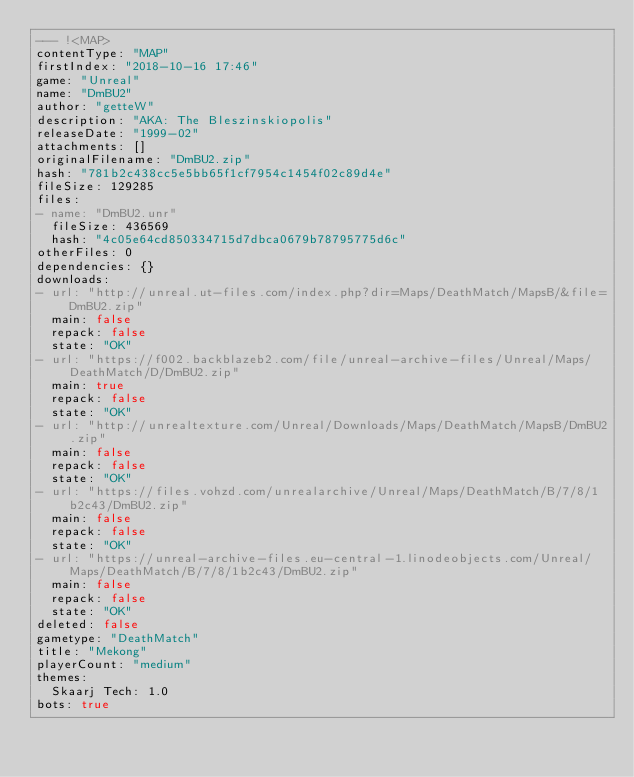Convert code to text. <code><loc_0><loc_0><loc_500><loc_500><_YAML_>--- !<MAP>
contentType: "MAP"
firstIndex: "2018-10-16 17:46"
game: "Unreal"
name: "DmBU2"
author: "getteW"
description: "AKA: The Bleszinskiopolis"
releaseDate: "1999-02"
attachments: []
originalFilename: "DmBU2.zip"
hash: "781b2c438cc5e5bb65f1cf7954c1454f02c89d4e"
fileSize: 129285
files:
- name: "DmBU2.unr"
  fileSize: 436569
  hash: "4c05e64cd850334715d7dbca0679b78795775d6c"
otherFiles: 0
dependencies: {}
downloads:
- url: "http://unreal.ut-files.com/index.php?dir=Maps/DeathMatch/MapsB/&file=DmBU2.zip"
  main: false
  repack: false
  state: "OK"
- url: "https://f002.backblazeb2.com/file/unreal-archive-files/Unreal/Maps/DeathMatch/D/DmBU2.zip"
  main: true
  repack: false
  state: "OK"
- url: "http://unrealtexture.com/Unreal/Downloads/Maps/DeathMatch/MapsB/DmBU2.zip"
  main: false
  repack: false
  state: "OK"
- url: "https://files.vohzd.com/unrealarchive/Unreal/Maps/DeathMatch/B/7/8/1b2c43/DmBU2.zip"
  main: false
  repack: false
  state: "OK"
- url: "https://unreal-archive-files.eu-central-1.linodeobjects.com/Unreal/Maps/DeathMatch/B/7/8/1b2c43/DmBU2.zip"
  main: false
  repack: false
  state: "OK"
deleted: false
gametype: "DeathMatch"
title: "Mekong"
playerCount: "medium"
themes:
  Skaarj Tech: 1.0
bots: true
</code> 